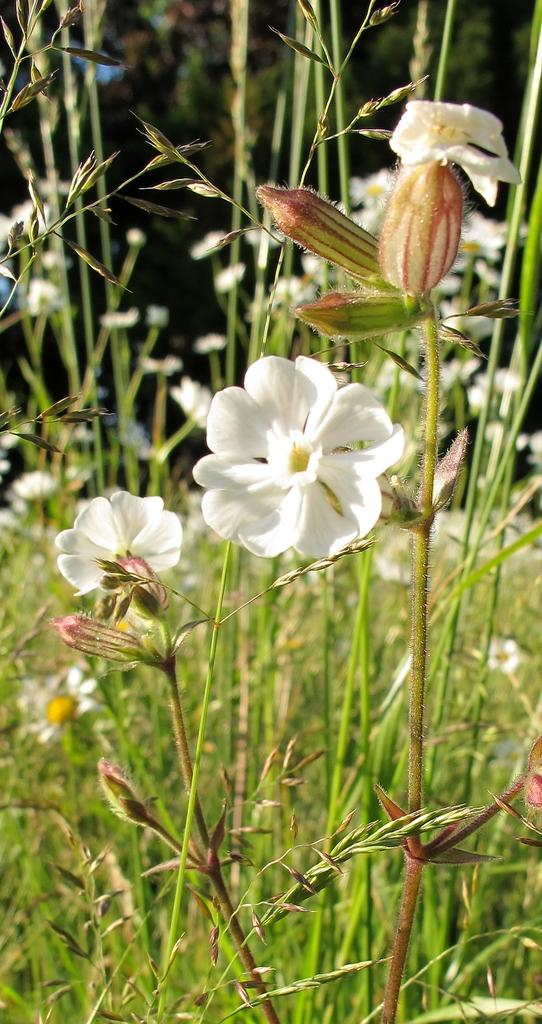What type of plants can be seen in the image? There are plants with flowers in the image. What can be seen in the background of the image? There are trees visible in the background of the image. What type of cherry is being eaten by the kitten in the image? There is no cherry or kitten present in the image; it features plants with flowers and trees in the background. 